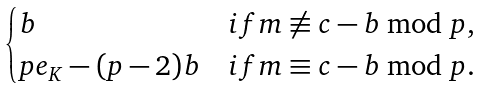Convert formula to latex. <formula><loc_0><loc_0><loc_500><loc_500>\begin{cases} b & i f m \not \equiv c - b \bmod p , \\ p e _ { K } - ( p - 2 ) b & i f m \equiv c - b \bmod p . \end{cases}</formula> 